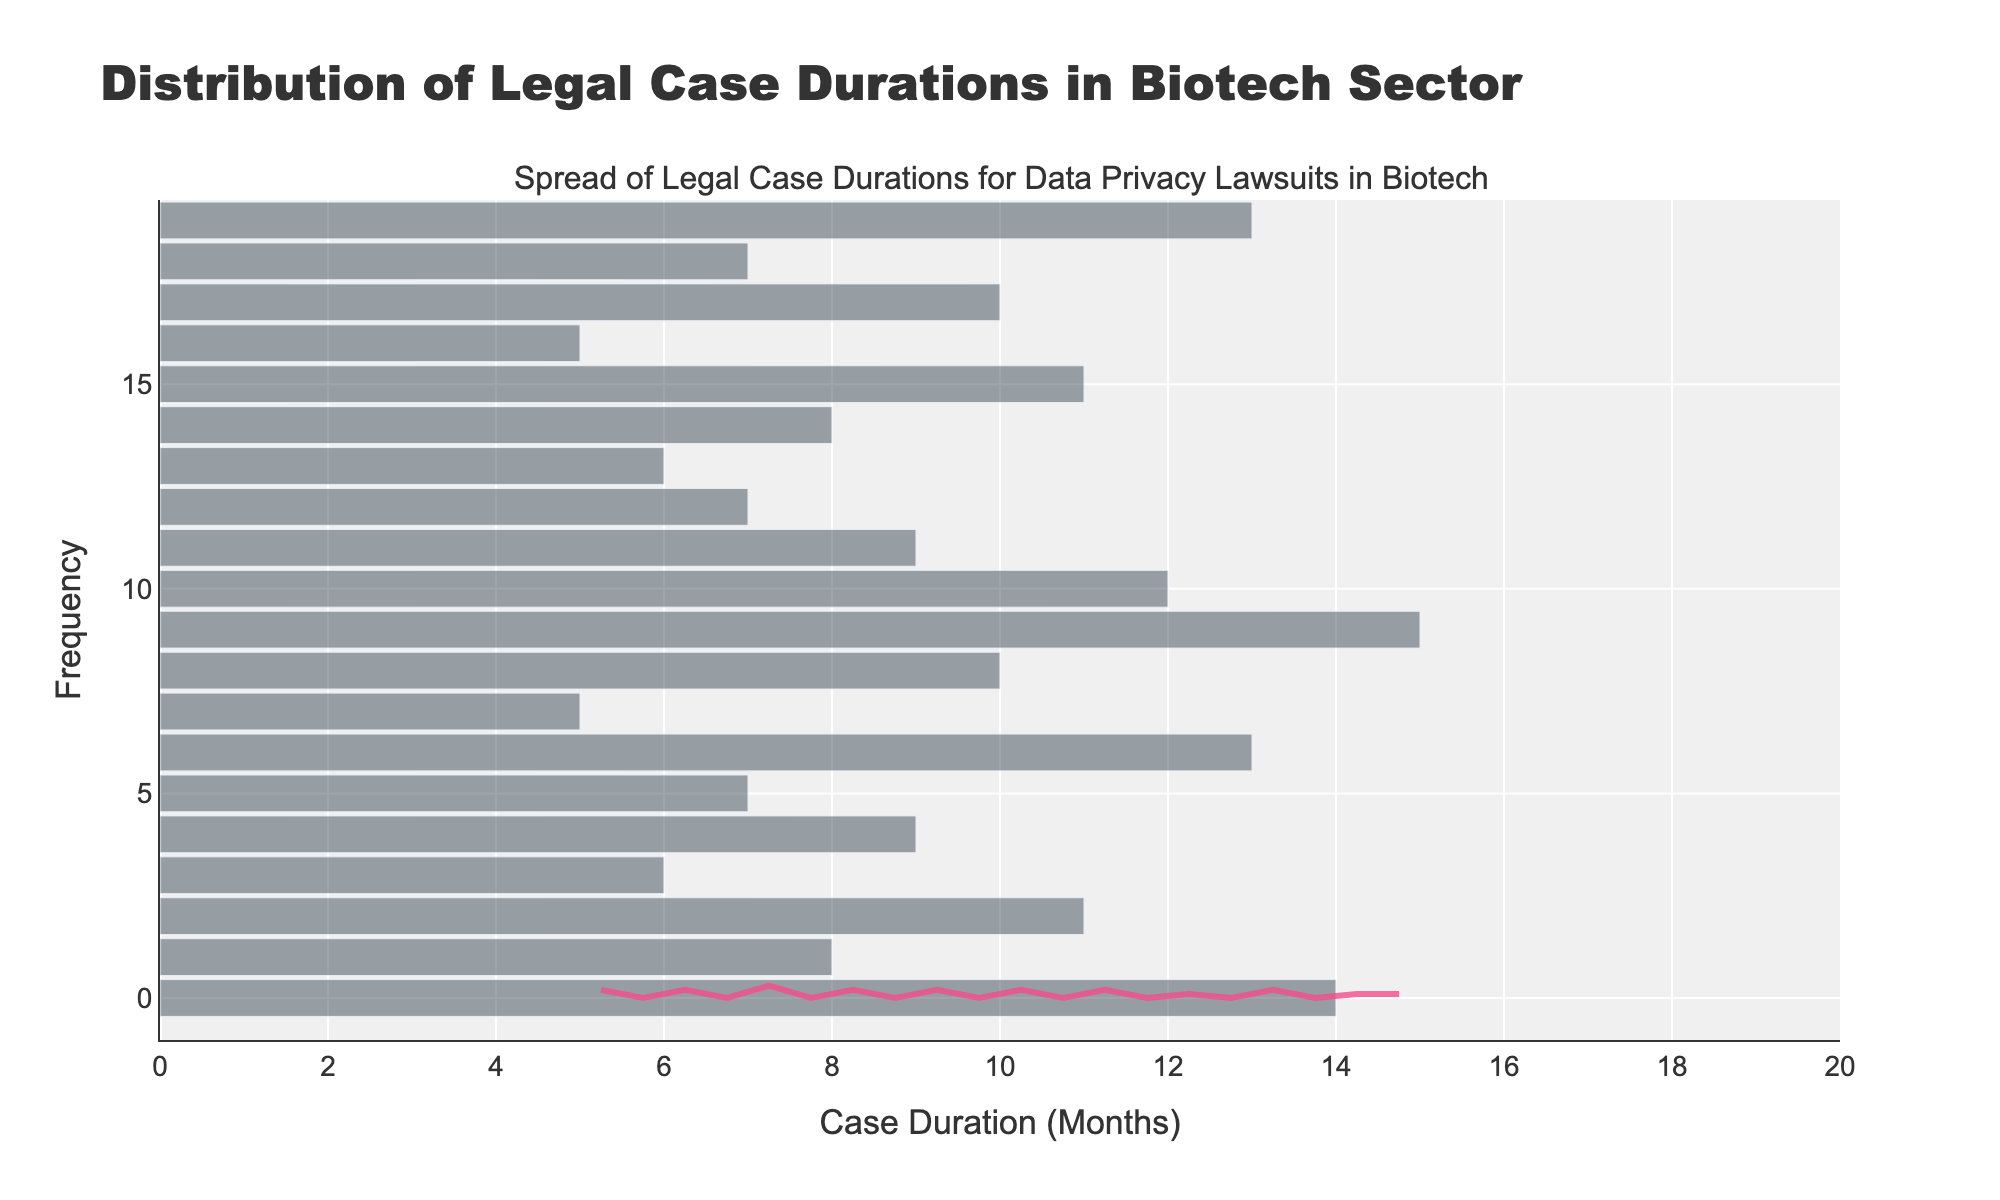What is the title of the figure? The title is located at the top of the figure and provides context for what the figure is depicting.
Answer: Distribution of Legal Case Durations in Biotech Sector How many bins are used in the histogram? The histogram displays data in discrete intervals called bins. Counting these bins reveals their number.
Answer: 20 What does the x-axis represent? The x-axis label indicates what is being measured along this axis in the figure.
Answer: Case Duration (Months) How many companies have a case duration of 7 months? Locate the bin corresponding to 7 months on the histogram and observe its height.
Answer: 3 What is the range of case durations displayed in the figure? Identify the minimum and maximum values on the x-axis to determine the range.
Answer: 5 to 15 months Which company has the longest case duration? Look at the highest bin or data point and refer to the data for the corresponding company.
Answer: Illumina How does the KDE (density curve) trend compared to the histogram bars? Observe the KDE curve and articulate its relationship to the histogram bars—how it smooths and represents the data.
Answer: It smooths out the bar peaks and valleys, showing the distribution density What is the most common duration for legal cases based on the histogram? Identify the tallest bin in the histogram to determine the most common case duration.
Answer: 7 months What is the approximate density value at 10 months on the KDE curve? Locate the x-axis value of 10 months on the KDE curve and note its y-axis (density) value.
Answer: Approximately 0.13 Which duration has more cases: 6 months or 8 months? Compare the heights of the histogram bins for 6 and 8-month durations.
Answer: 8 months 